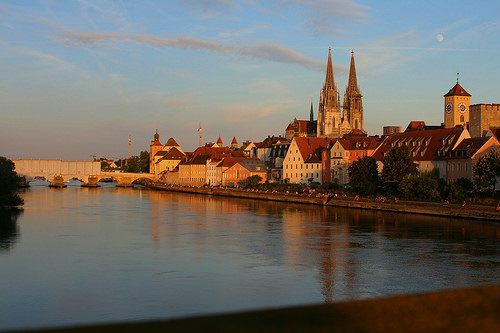<image>
Is the bridge on the water? Yes. Looking at the image, I can see the bridge is positioned on top of the water, with the water providing support. Where is the tree in relation to the water? Is it in the water? No. The tree is not contained within the water. These objects have a different spatial relationship. Is there a cloud above the water? Yes. The cloud is positioned above the water in the vertical space, higher up in the scene. 